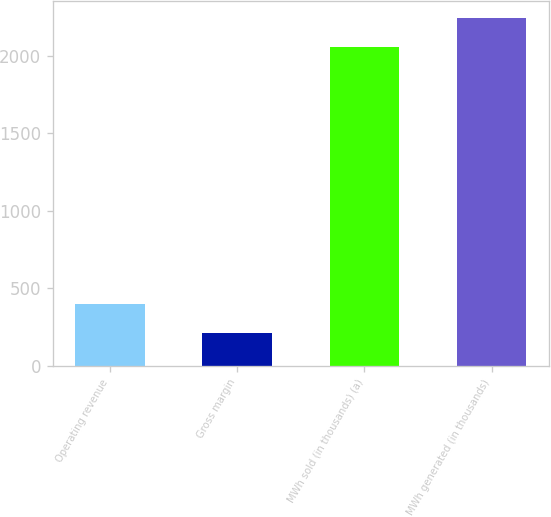Convert chart. <chart><loc_0><loc_0><loc_500><loc_500><bar_chart><fcel>Operating revenue<fcel>Gross margin<fcel>MWh sold (in thousands) (a)<fcel>MWh generated (in thousands)<nl><fcel>400.9<fcel>215<fcel>2053<fcel>2238.9<nl></chart> 